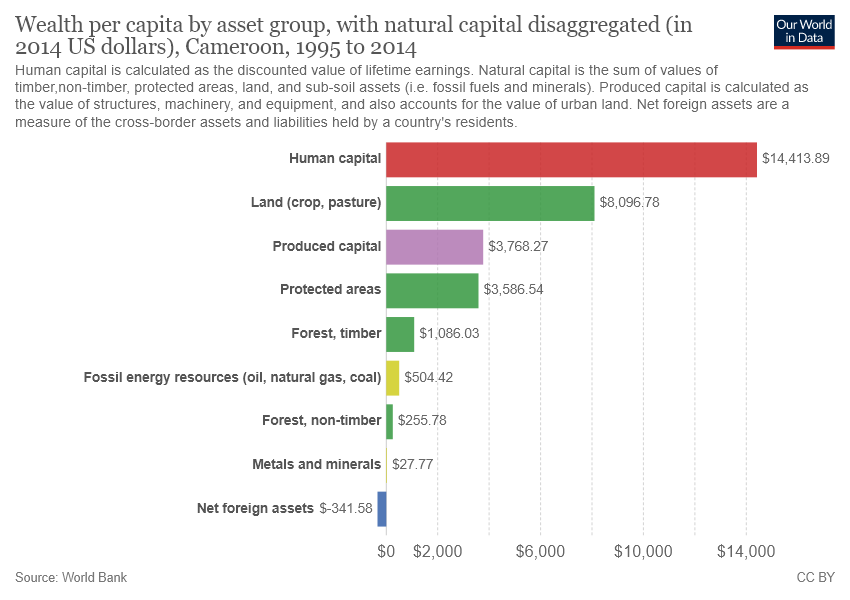Highlight a few significant elements in this photo. The color of the longest bar is red. The sum of all green bars is not greater than the red bar. 